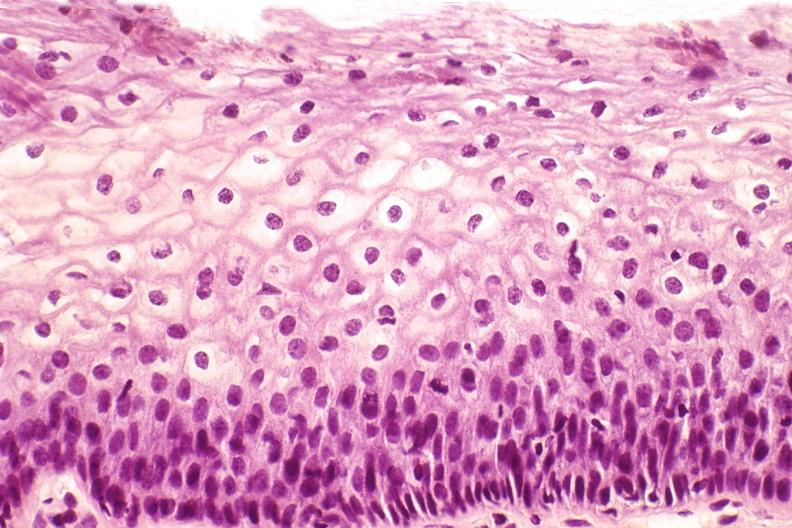where is this from?
Answer the question using a single word or phrase. Female reproductive system 